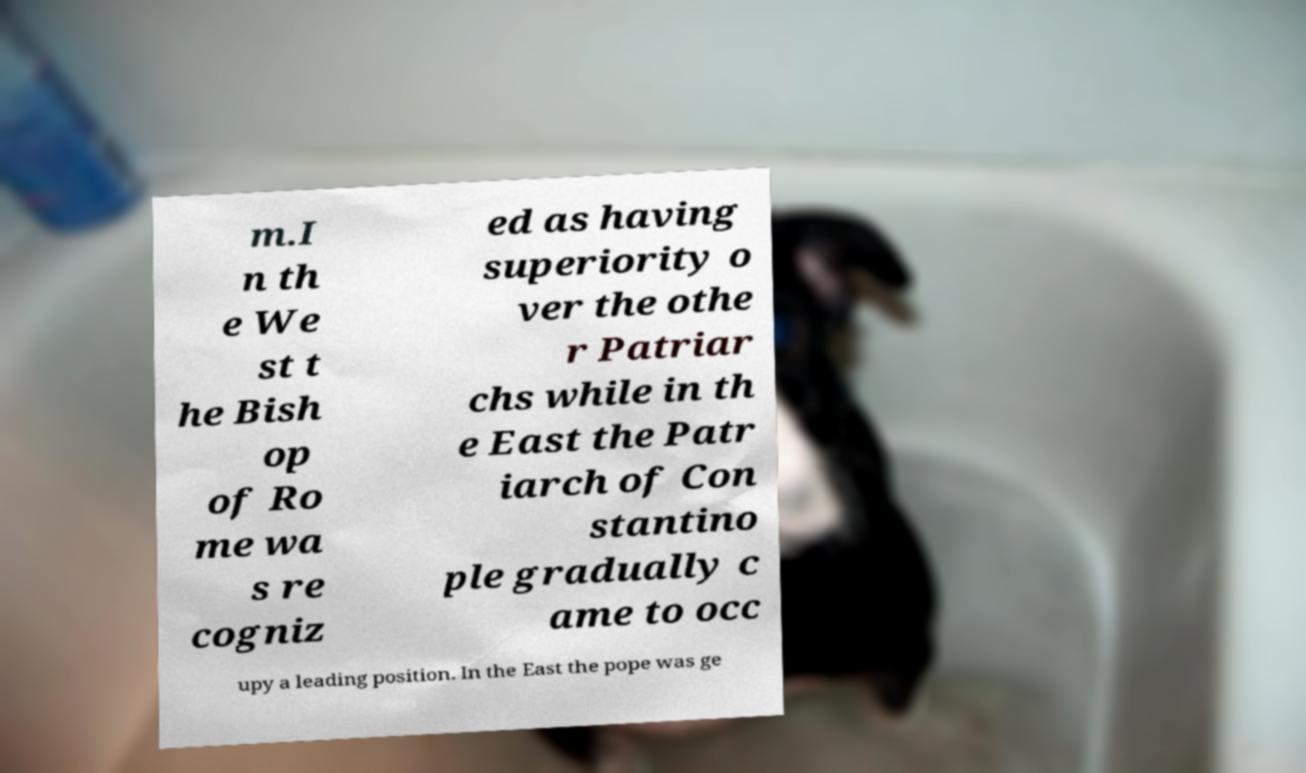Could you extract and type out the text from this image? m.I n th e We st t he Bish op of Ro me wa s re cogniz ed as having superiority o ver the othe r Patriar chs while in th e East the Patr iarch of Con stantino ple gradually c ame to occ upy a leading position. In the East the pope was ge 